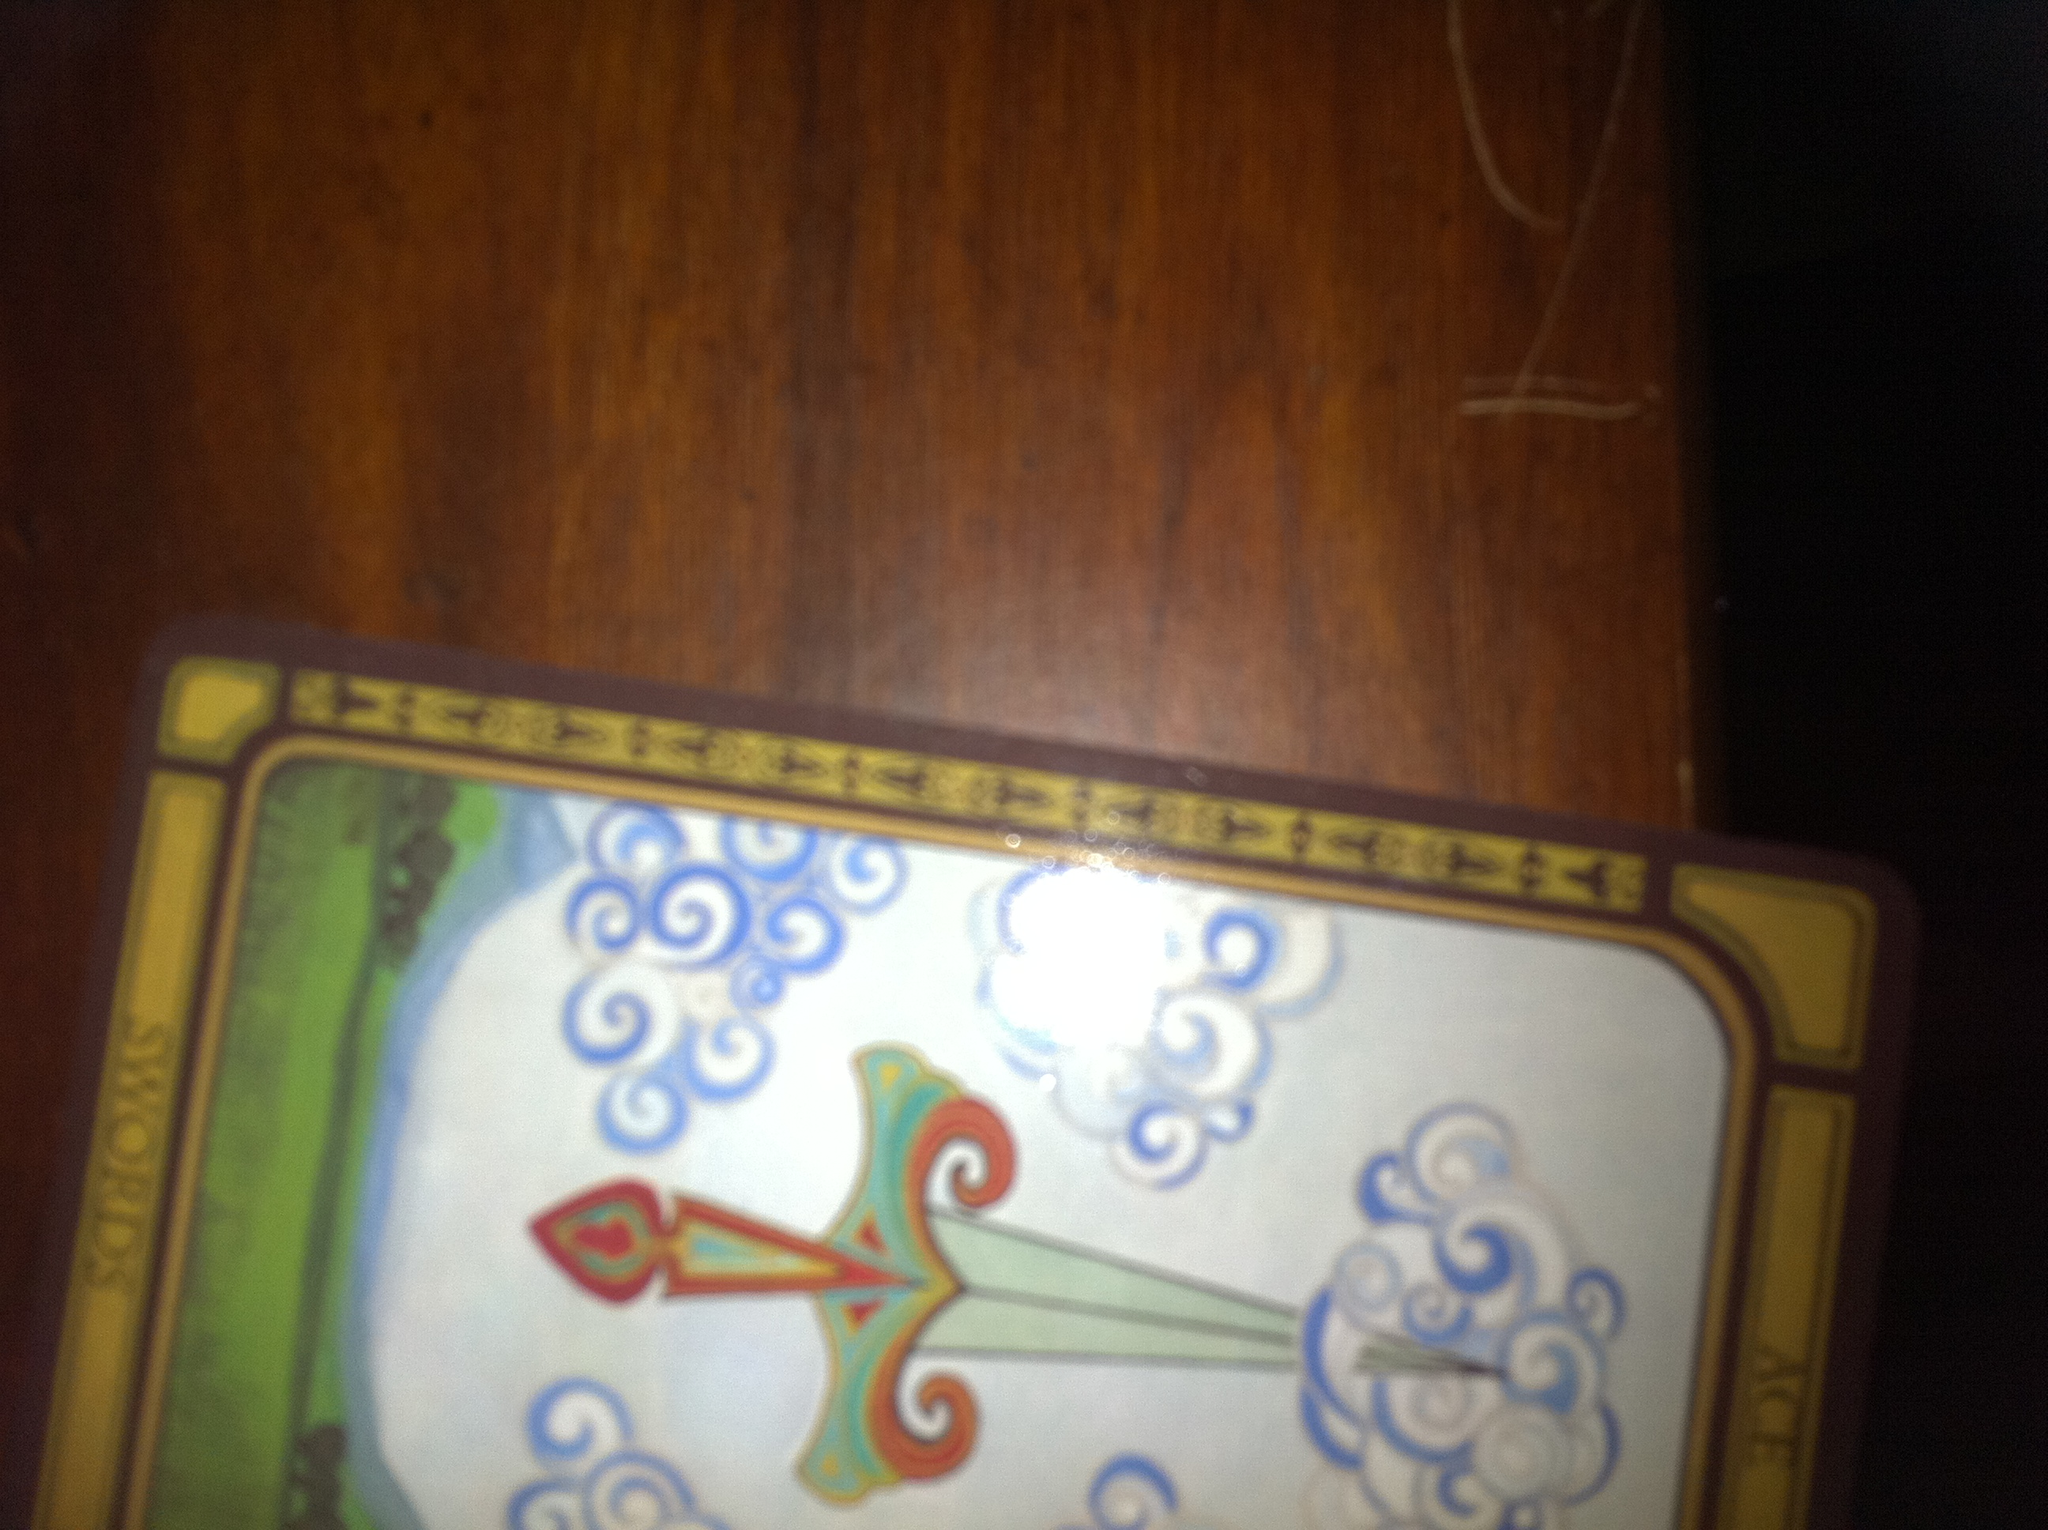Can you provide some meaning or interpretation of this card? The Ace of Swords typically represents new beginnings, clarity, and intellectual power. This card often signifies that a moment of breakthrough or a new understanding is on the horizon. The imagery of the sword cutting through clouds can symbolize cutting through confusion or obstacles with sharp intellect. 